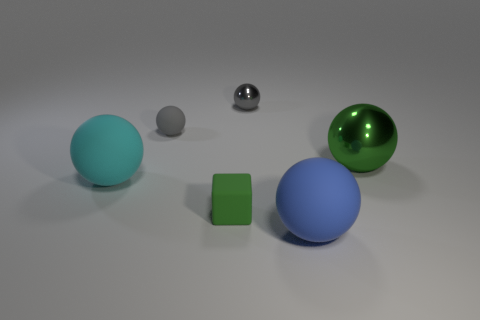Subtract 2 spheres. How many spheres are left? 3 Subtract all cyan balls. How many balls are left? 4 Subtract all blue matte spheres. How many spheres are left? 4 Subtract all red spheres. Subtract all blue blocks. How many spheres are left? 5 Add 4 large blue things. How many objects exist? 10 Subtract all balls. How many objects are left? 1 Add 5 small metal spheres. How many small metal spheres are left? 6 Add 5 big green objects. How many big green objects exist? 6 Subtract 1 cyan spheres. How many objects are left? 5 Subtract all small metallic balls. Subtract all gray metal spheres. How many objects are left? 4 